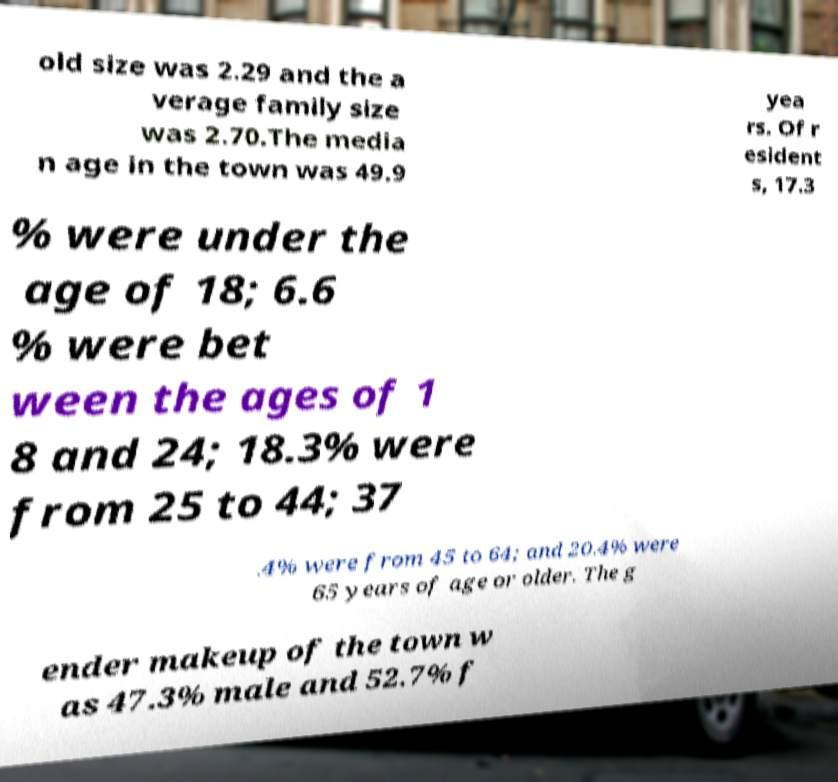For documentation purposes, I need the text within this image transcribed. Could you provide that? old size was 2.29 and the a verage family size was 2.70.The media n age in the town was 49.9 yea rs. Of r esident s, 17.3 % were under the age of 18; 6.6 % were bet ween the ages of 1 8 and 24; 18.3% were from 25 to 44; 37 .4% were from 45 to 64; and 20.4% were 65 years of age or older. The g ender makeup of the town w as 47.3% male and 52.7% f 